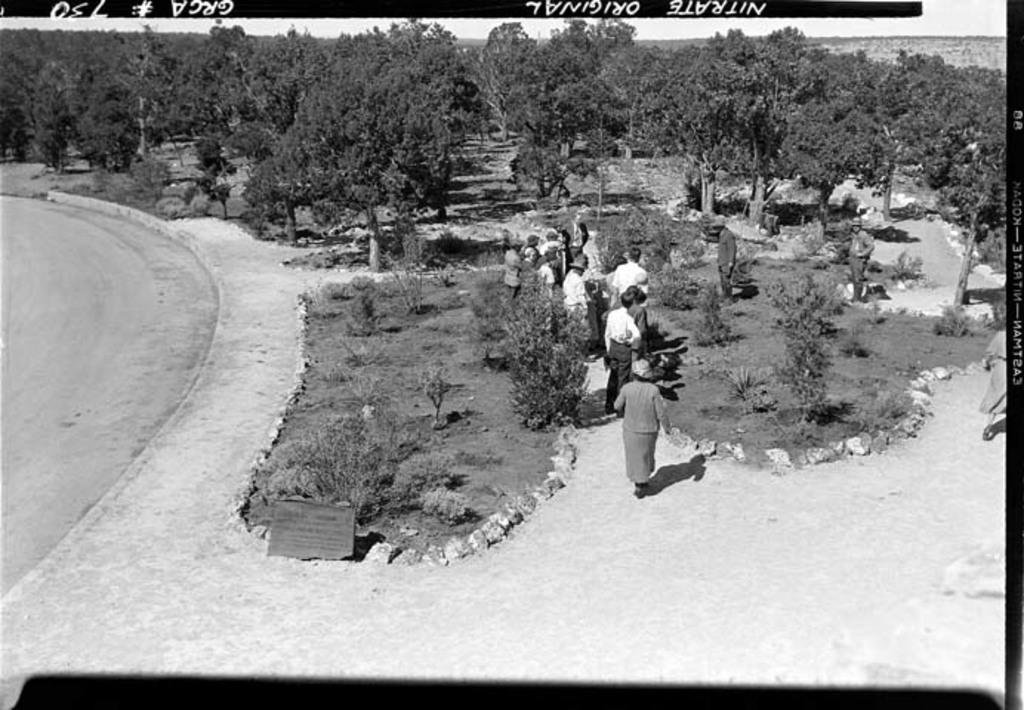What type of picture is in the image? The image contains a black and white picture. What is happening in the picture? The picture depicts a group of people standing on the ground. What can be seen in the background of the picture? There is a group of trees and the sky visible in the background of the image. Where is the jar of jelly located in the image? There is no jar of jelly present in the image. Can you describe the lake in the image? There is no lake present in the image. 